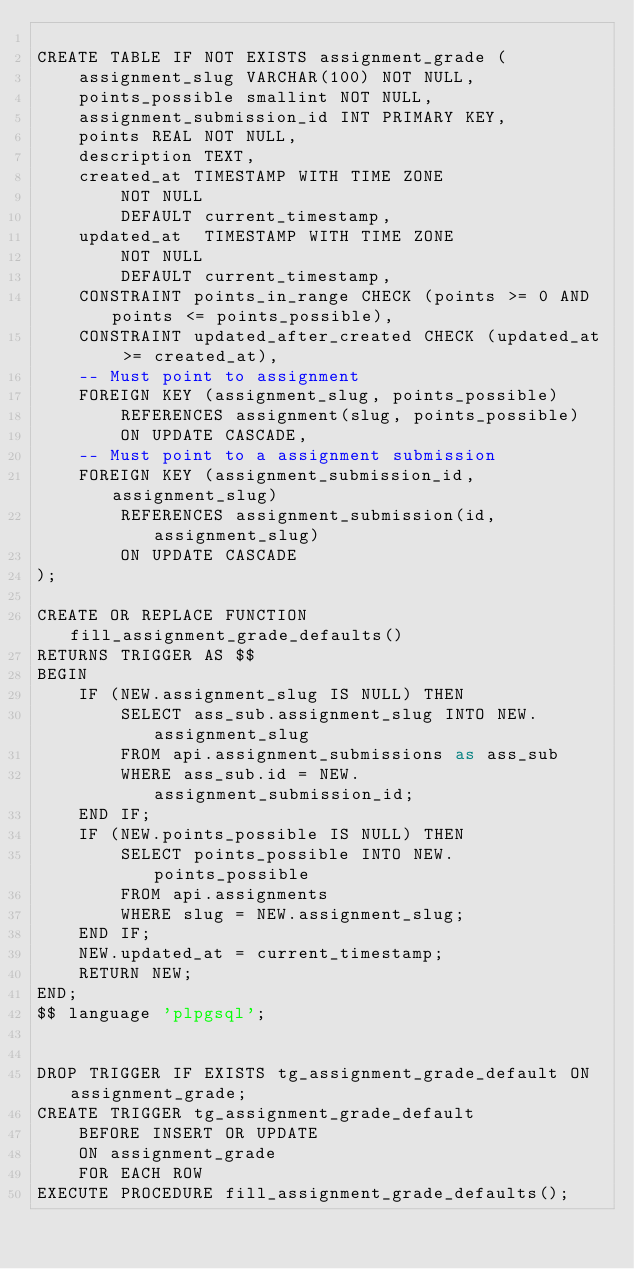Convert code to text. <code><loc_0><loc_0><loc_500><loc_500><_SQL_>
CREATE TABLE IF NOT EXISTS assignment_grade (
    assignment_slug VARCHAR(100) NOT NULL,
    points_possible smallint NOT NULL,
    assignment_submission_id INT PRIMARY KEY,
    points REAL NOT NULL,
    description TEXT,
    created_at TIMESTAMP WITH TIME ZONE
        NOT NULL
        DEFAULT current_timestamp,
    updated_at  TIMESTAMP WITH TIME ZONE
        NOT NULL
        DEFAULT current_timestamp,
    CONSTRAINT points_in_range CHECK (points >= 0 AND points <= points_possible),
    CONSTRAINT updated_after_created CHECK (updated_at >= created_at),
    -- Must point to assignment
    FOREIGN KEY (assignment_slug, points_possible)
        REFERENCES assignment(slug, points_possible)
        ON UPDATE CASCADE,
    -- Must point to a assignment submission
    FOREIGN KEY (assignment_submission_id, assignment_slug)
        REFERENCES assignment_submission(id, assignment_slug)
        ON UPDATE CASCADE
);

CREATE OR REPLACE FUNCTION fill_assignment_grade_defaults()
RETURNS TRIGGER AS $$
BEGIN
    IF (NEW.assignment_slug IS NULL) THEN
        SELECT ass_sub.assignment_slug INTO NEW.assignment_slug
        FROM api.assignment_submissions as ass_sub
        WHERE ass_sub.id = NEW.assignment_submission_id;
    END IF;
    IF (NEW.points_possible IS NULL) THEN
        SELECT points_possible INTO NEW.points_possible
        FROM api.assignments
        WHERE slug = NEW.assignment_slug;
    END IF;
    NEW.updated_at = current_timestamp;
    RETURN NEW;
END;
$$ language 'plpgsql';


DROP TRIGGER IF EXISTS tg_assignment_grade_default ON assignment_grade;
CREATE TRIGGER tg_assignment_grade_default
    BEFORE INSERT OR UPDATE
    ON assignment_grade
    FOR EACH ROW
EXECUTE PROCEDURE fill_assignment_grade_defaults();
</code> 